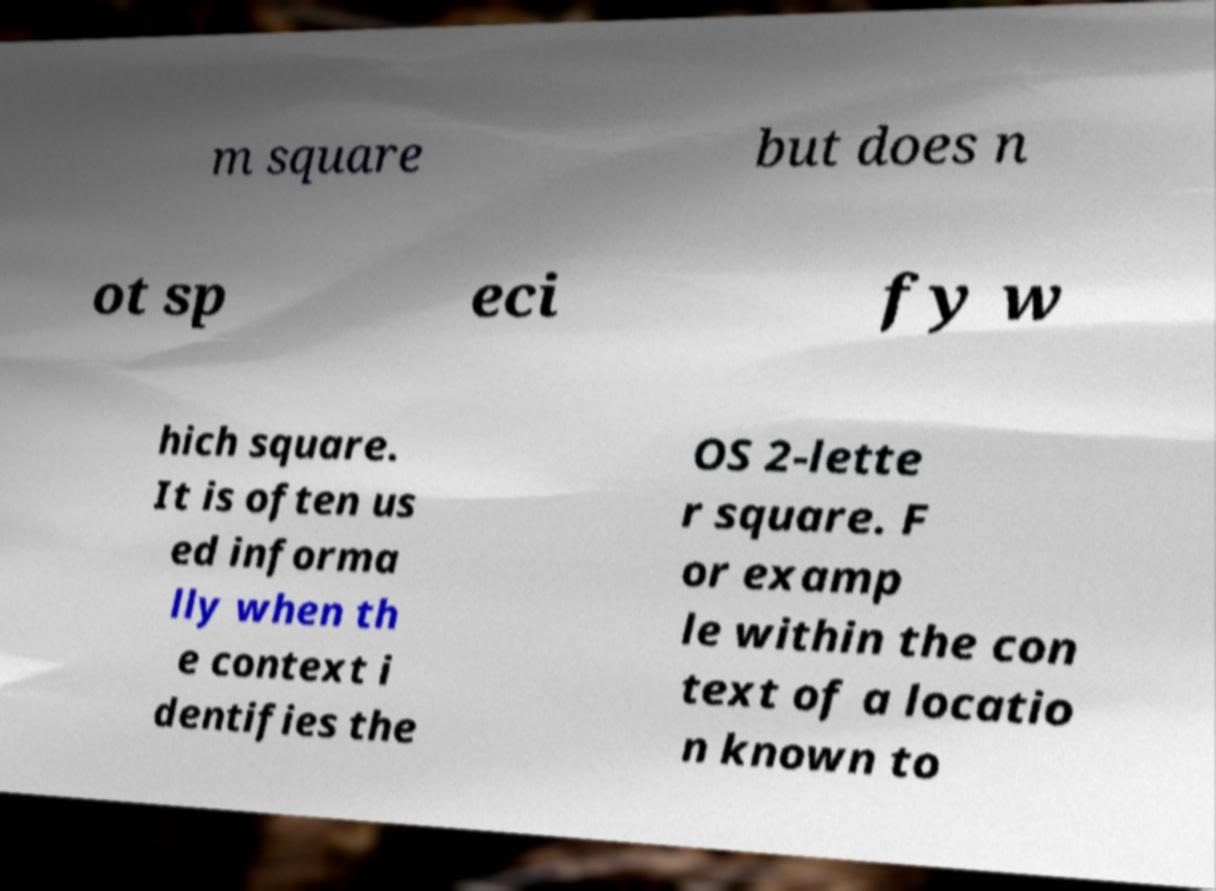For documentation purposes, I need the text within this image transcribed. Could you provide that? m square but does n ot sp eci fy w hich square. It is often us ed informa lly when th e context i dentifies the OS 2-lette r square. F or examp le within the con text of a locatio n known to 